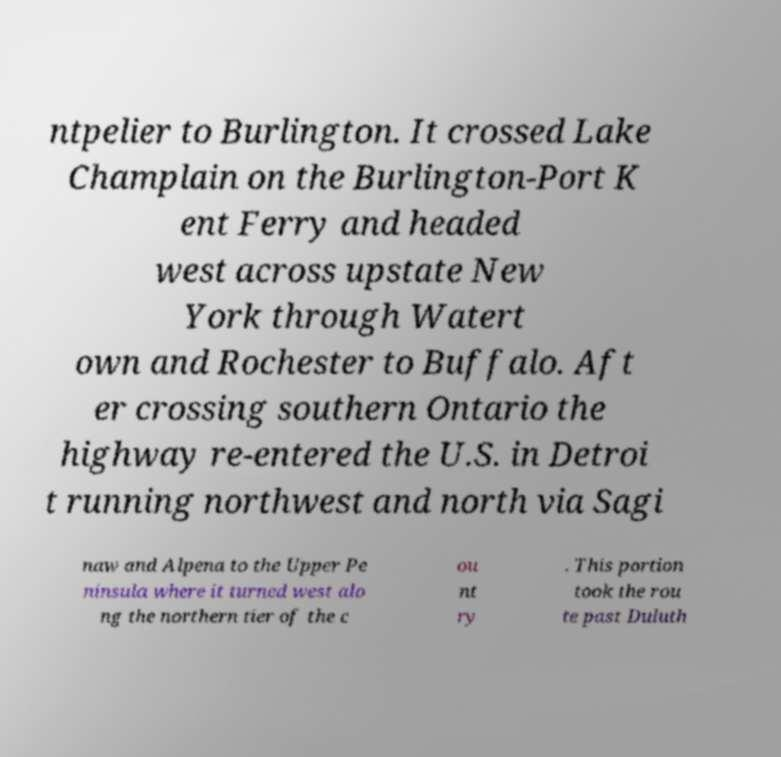What messages or text are displayed in this image? I need them in a readable, typed format. ntpelier to Burlington. It crossed Lake Champlain on the Burlington-Port K ent Ferry and headed west across upstate New York through Watert own and Rochester to Buffalo. Aft er crossing southern Ontario the highway re-entered the U.S. in Detroi t running northwest and north via Sagi naw and Alpena to the Upper Pe ninsula where it turned west alo ng the northern tier of the c ou nt ry . This portion took the rou te past Duluth 